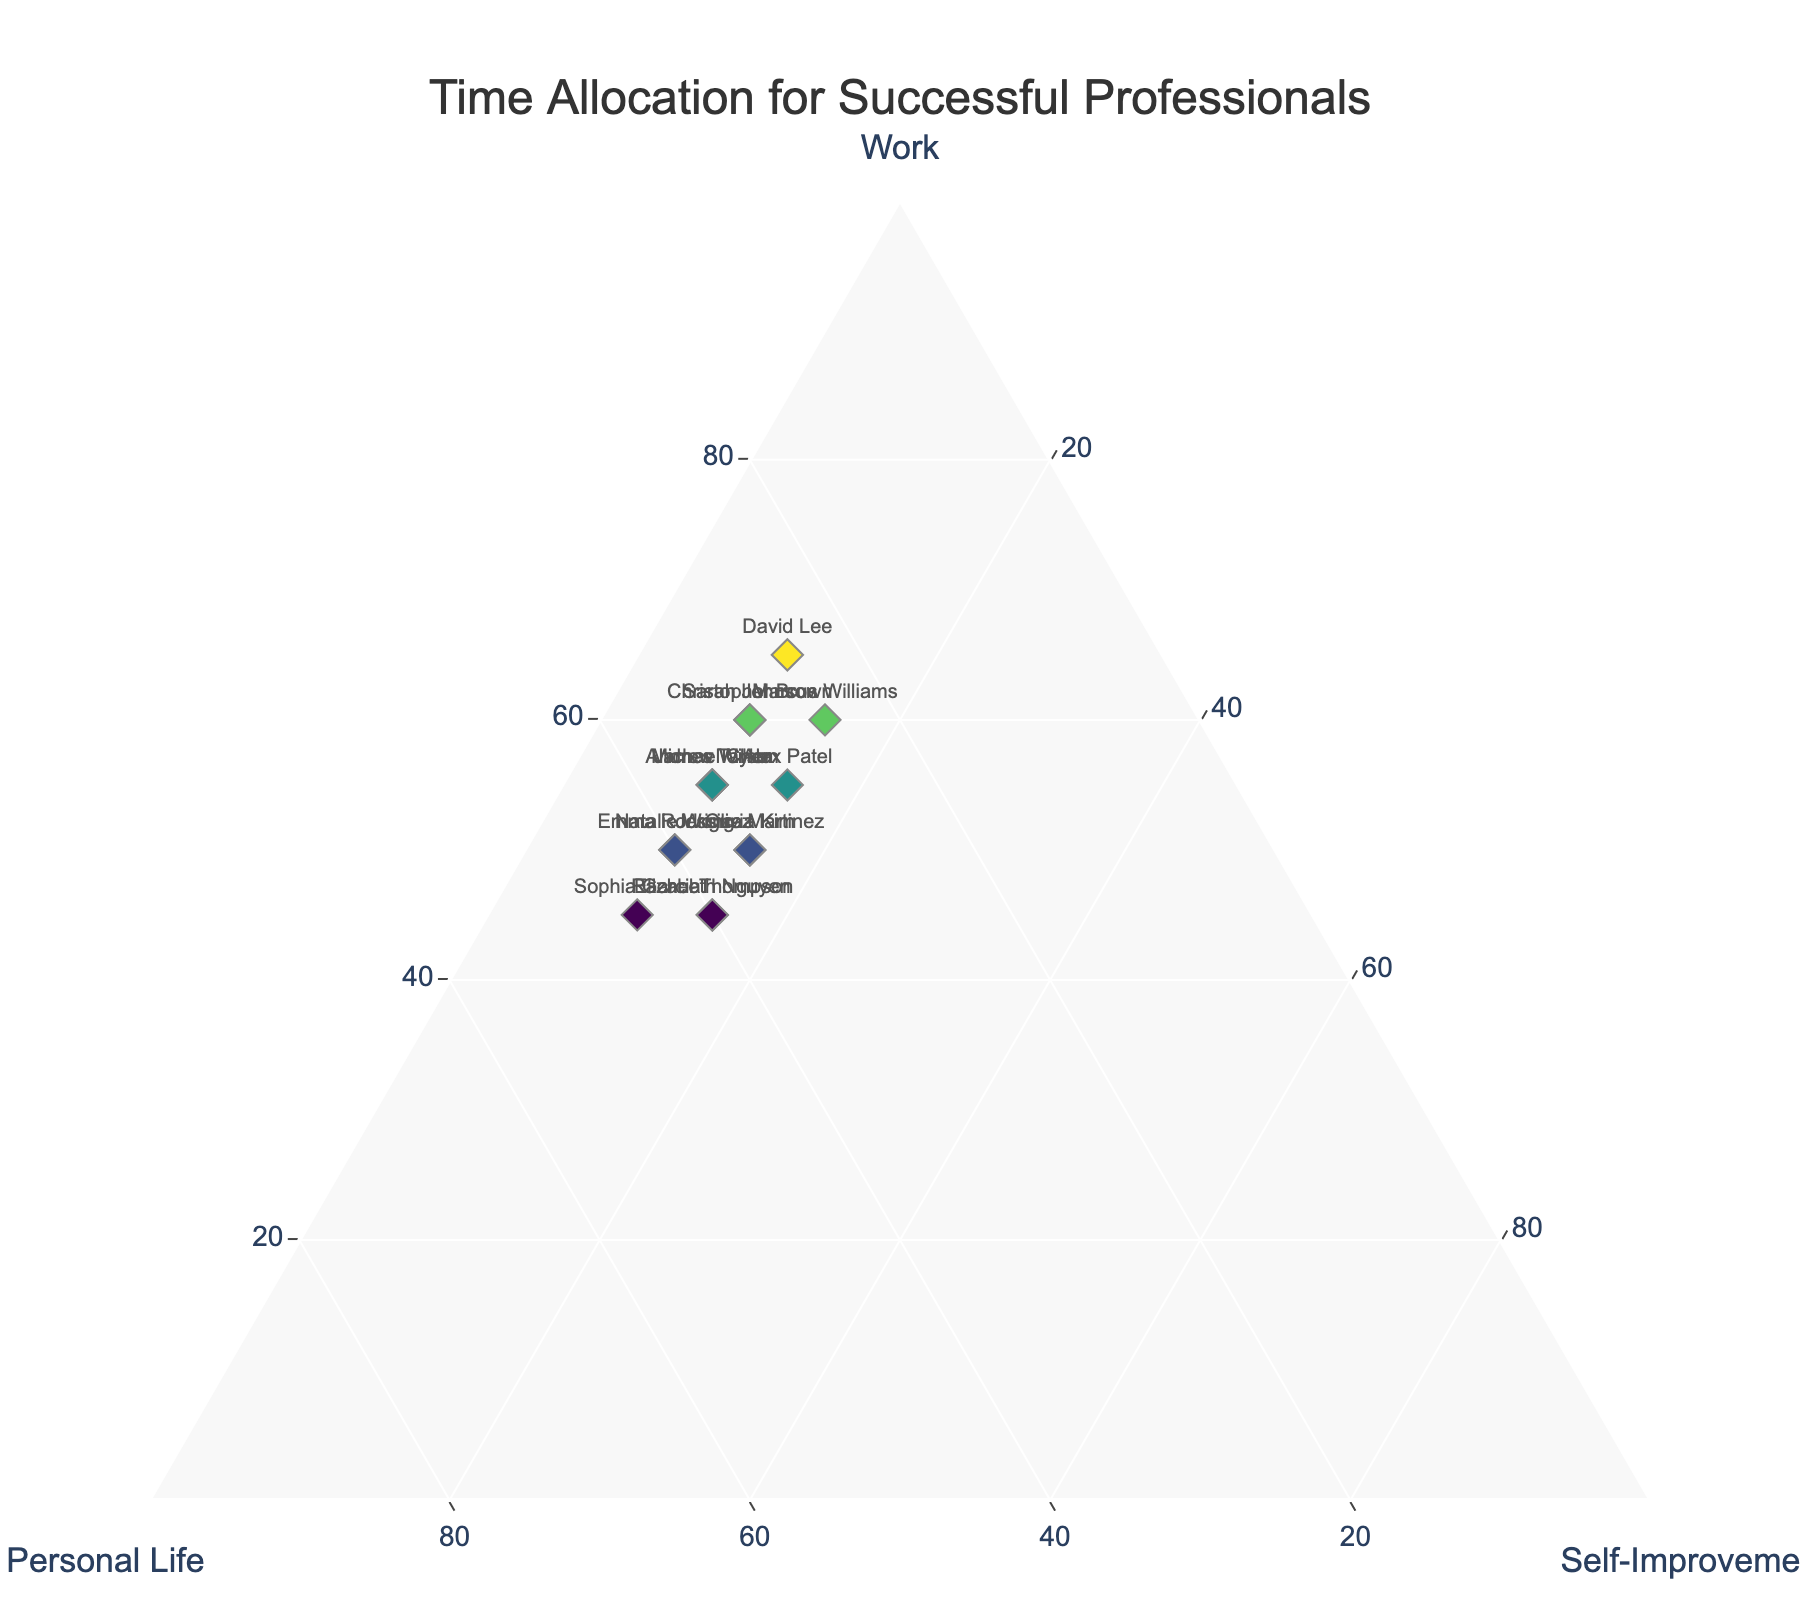What is the title of the ternary plot? The title is prominently displayed at the top center of the plot, providing an overview of the content being visualized.
Answer: Time Allocation for Successful Professionals How many professionals allocated 10% of their time to Self-Improvement? By looking at the plot, we can identify the points where the self-improvement axis is marked at 10%. Count these points to find the number of professionals.
Answer: 7 Which professional allocates 60% of their time to Work and 30% to Personal Life? Locate the data point with the work axis at 60% and personal life axis at 30%. The text label next to this data point provides the professional's name.
Answer: Sarah Johnson What is the average percentage of time allocated to Work by the professionals? Sum the percentages of Work for all professionals and divide by the number of professionals (15). (60+55+50+65+45+55+50+60+45+55+50+60+45+55+50) / 15 = 54.67%
Answer: 54.67% Which professional allocates the most time to Personal Life? Find the data point that reaches the highest percentage on the personal life axis. The text label next to this data point gives the professional's name.
Answer: Sophia Garcia How many professionals allocate more time to Personal Life than to Work? Compare the Personal Life percentage against the Work percentage for each professional. Count the cases where Personal Life is greater than Work.
Answer: 1 List the professionals who allocate 15% of their time to Self-Improvement. Identify data points along the self-improvement axis at 15%. The text labels next to these data points give the professionals' names.
Answer: Rachel Thompson, Alex Patel, Olivia Kim, Marcus Williams, Elizabeth Nguyen, Jessica Martinez What is the sum of the percentages for Work, Personal Life, and Self-Improvement for Rachel Thompson? For Rachel Thompson, sum the percentages of Work, Personal Life, and Self-Improvement. 45% + 40% + 15% = 100%
Answer: 100% Who allocates equal time to Personal Life and Self-Improvement? Locate the data point where the Personal Life percentage equals the Self-Improvement percentage. The text label next to this data point indicates the professional's name.
Answer: No professional Which professional has the same Work allocation but different Personal Life and Self-Improvement allocations compared to Michael Chen? Find a data point with the same Work percentage as Michael Chen (55%), and different values for Personal Life and Self-Improvement.
Answer: Alex Patel 